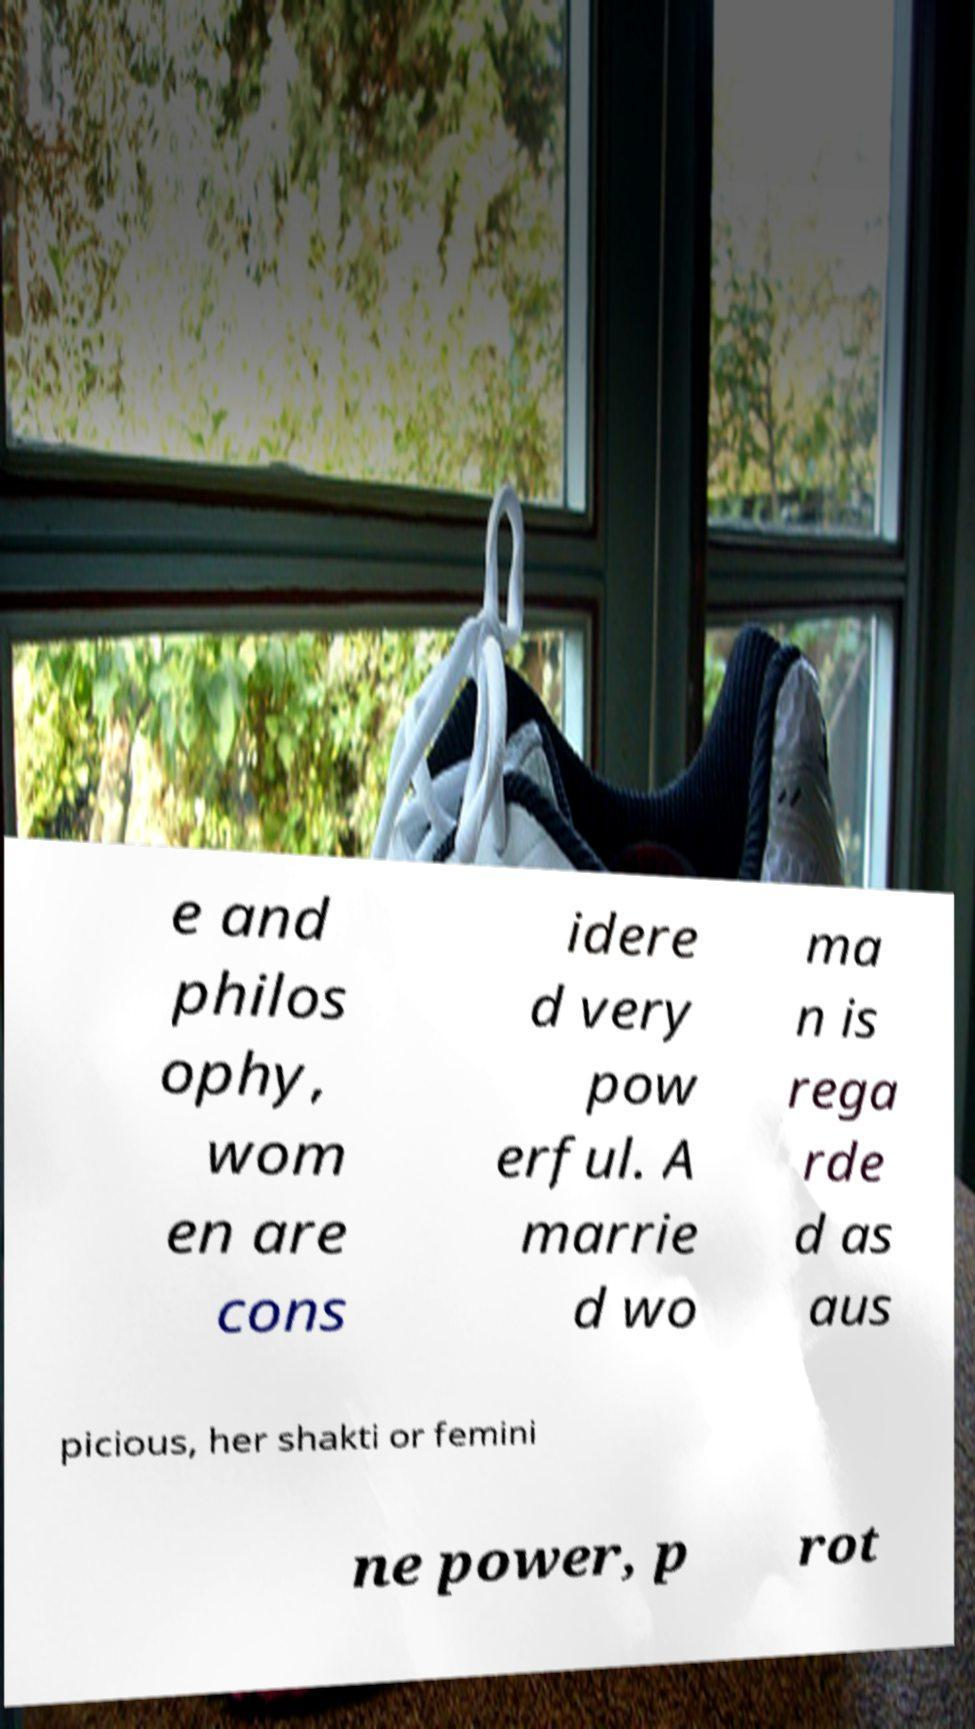Could you extract and type out the text from this image? e and philos ophy, wom en are cons idere d very pow erful. A marrie d wo ma n is rega rde d as aus picious, her shakti or femini ne power, p rot 